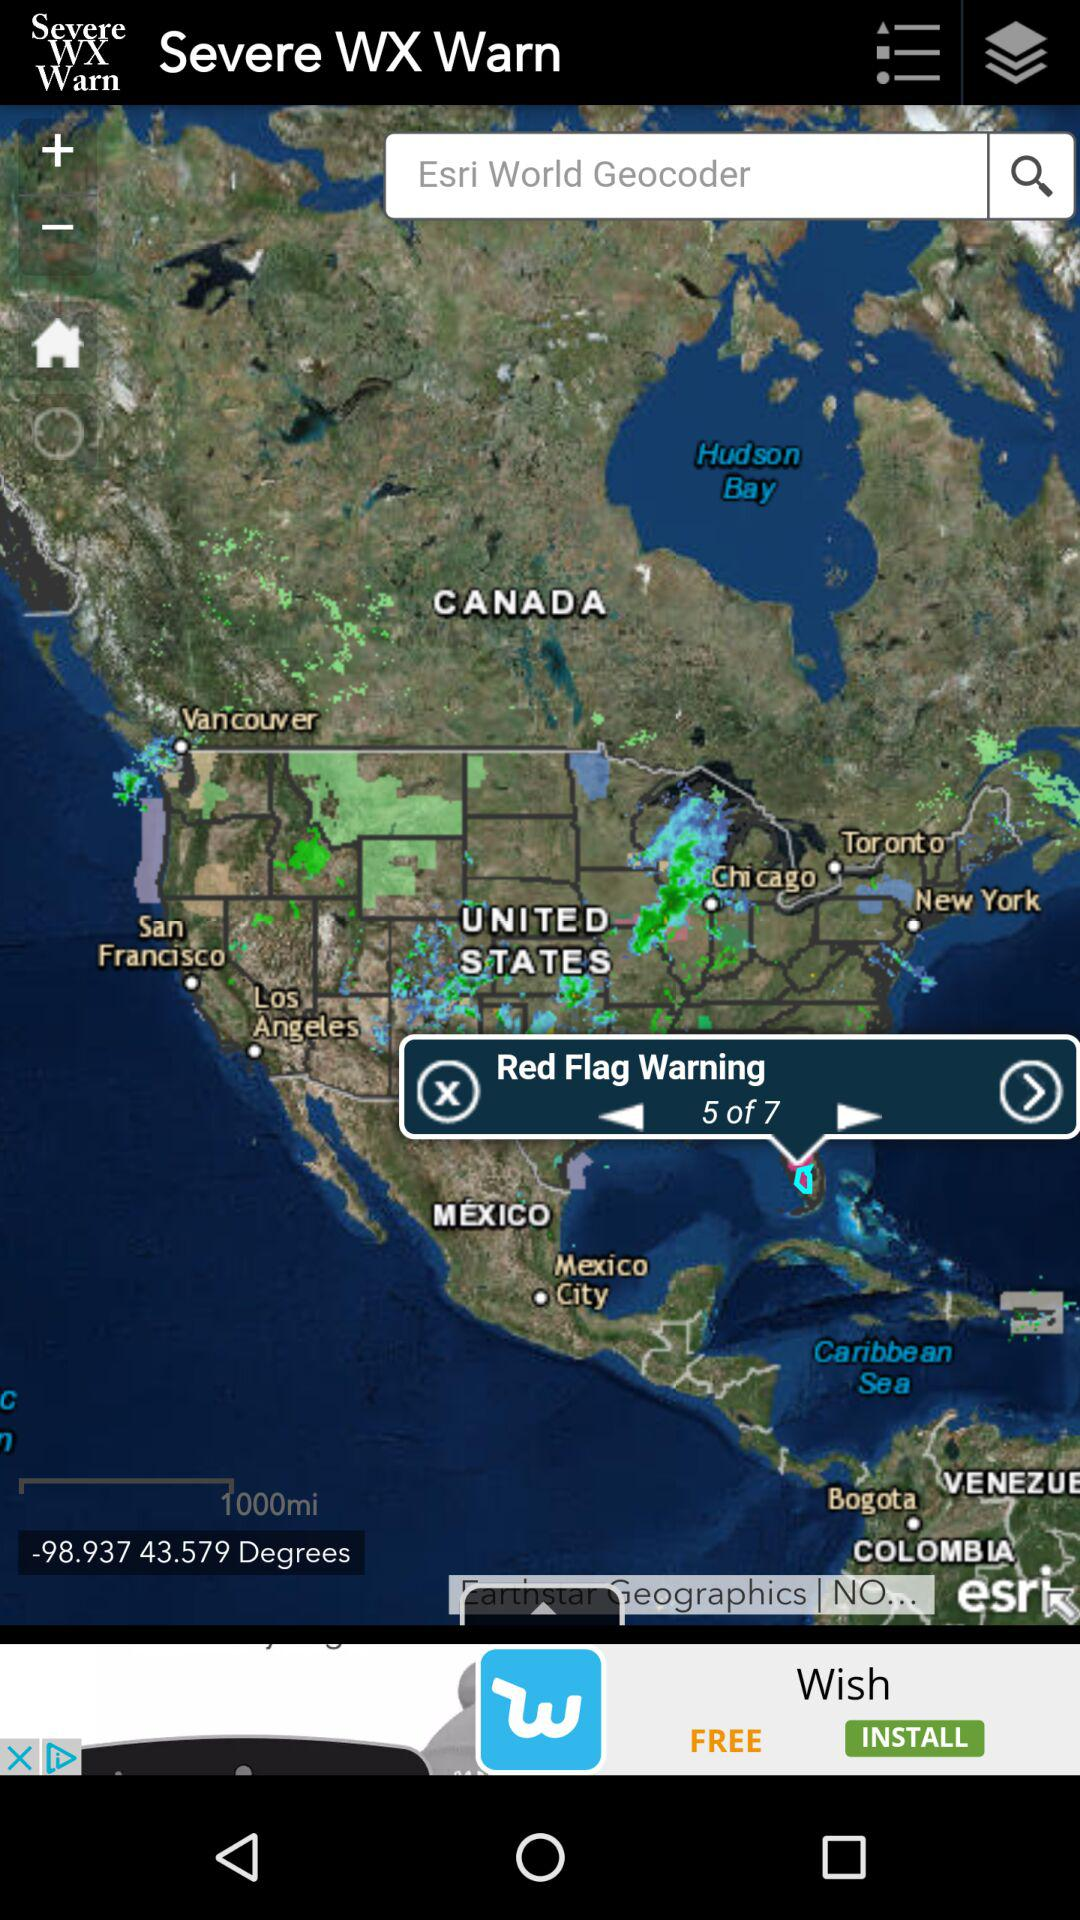How many degrees am I looking at on the map? You are looking at -98.937 43.579 degrees. 